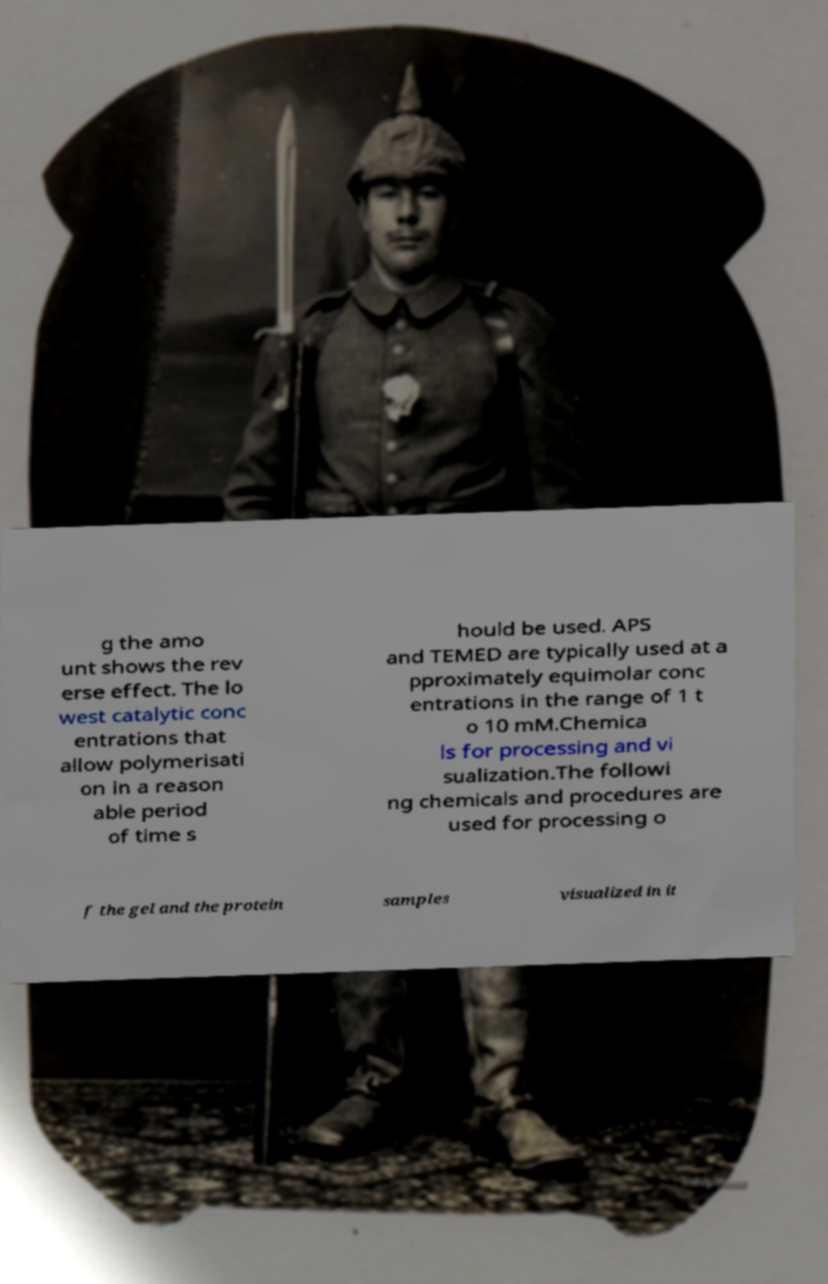There's text embedded in this image that I need extracted. Can you transcribe it verbatim? g the amo unt shows the rev erse effect. The lo west catalytic conc entrations that allow polymerisati on in a reason able period of time s hould be used. APS and TEMED are typically used at a pproximately equimolar conc entrations in the range of 1 t o 10 mM.Chemica ls for processing and vi sualization.The followi ng chemicals and procedures are used for processing o f the gel and the protein samples visualized in it 